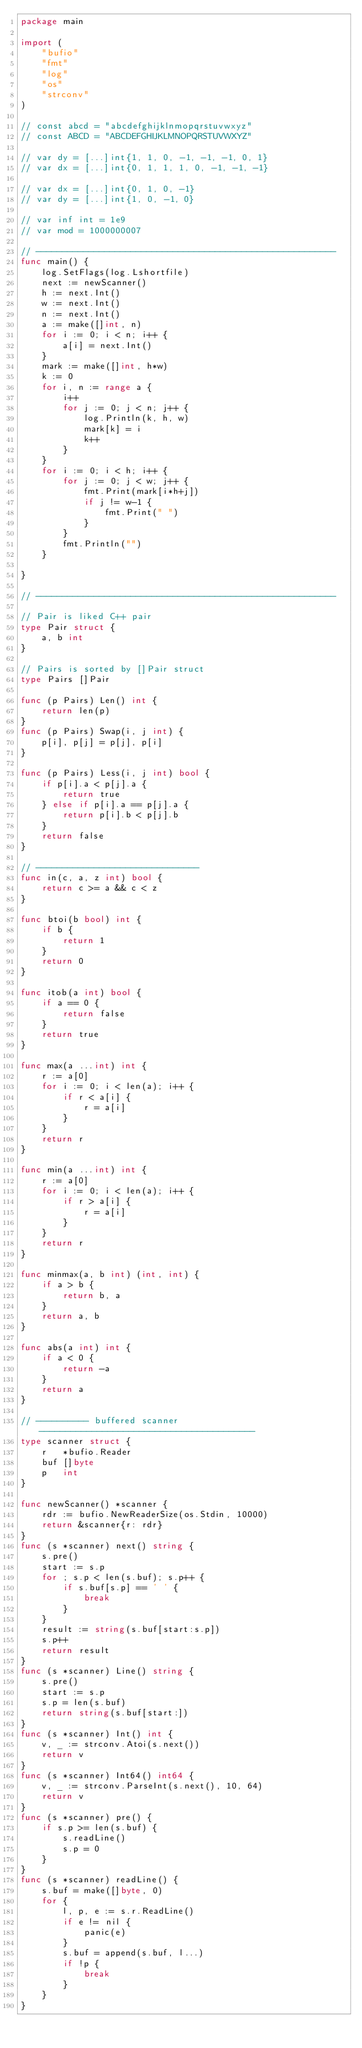Convert code to text. <code><loc_0><loc_0><loc_500><loc_500><_Go_>package main

import (
	"bufio"
	"fmt"
	"log"
	"os"
	"strconv"
)

// const abcd = "abcdefghijklnmopqrstuvwxyz"
// const ABCD = "ABCDEFGHIJKLMNOPQRSTUVWXYZ"

// var dy = [...]int{1, 1, 0, -1, -1, -1, 0, 1}
// var dx = [...]int{0, 1, 1, 1, 0, -1, -1, -1}

// var dx = [...]int{0, 1, 0, -1}
// var dy = [...]int{1, 0, -1, 0}

// var inf int = 1e9
// var mod = 1000000007

// ---------------------------------------------------------
func main() {
	log.SetFlags(log.Lshortfile)
	next := newScanner()
	h := next.Int()
	w := next.Int()
	n := next.Int()
	a := make([]int, n)
	for i := 0; i < n; i++ {
		a[i] = next.Int()
	}
	mark := make([]int, h*w)
	k := 0
	for i, n := range a {
		i++
		for j := 0; j < n; j++ {
			log.Println(k, h, w)
			mark[k] = i
			k++
		}
	}
	for i := 0; i < h; i++ {
		for j := 0; j < w; j++ {
			fmt.Print(mark[i*h+j])
			if j != w-1 {
				fmt.Print(" ")
			}
		}
		fmt.Println("")
	}

}

// ---------------------------------------------------------

// Pair is liked C++ pair
type Pair struct {
	a, b int
}

// Pairs is sorted by []Pair struct
type Pairs []Pair

func (p Pairs) Len() int {
	return len(p)
}
func (p Pairs) Swap(i, j int) {
	p[i], p[j] = p[j], p[i]
}

func (p Pairs) Less(i, j int) bool {
	if p[i].a < p[j].a {
		return true
	} else if p[i].a == p[j].a {
		return p[i].b < p[j].b
	}
	return false
}

// -------------------------------
func in(c, a, z int) bool {
	return c >= a && c < z
}

func btoi(b bool) int {
	if b {
		return 1
	}
	return 0
}

func itob(a int) bool {
	if a == 0 {
		return false
	}
	return true
}

func max(a ...int) int {
	r := a[0]
	for i := 0; i < len(a); i++ {
		if r < a[i] {
			r = a[i]
		}
	}
	return r
}

func min(a ...int) int {
	r := a[0]
	for i := 0; i < len(a); i++ {
		if r > a[i] {
			r = a[i]
		}
	}
	return r
}

func minmax(a, b int) (int, int) {
	if a > b {
		return b, a
	}
	return a, b
}

func abs(a int) int {
	if a < 0 {
		return -a
	}
	return a
}

// ---------- buffered scanner -----------------------------------------
type scanner struct {
	r   *bufio.Reader
	buf []byte
	p   int
}

func newScanner() *scanner {
	rdr := bufio.NewReaderSize(os.Stdin, 10000)
	return &scanner{r: rdr}
}
func (s *scanner) next() string {
	s.pre()
	start := s.p
	for ; s.p < len(s.buf); s.p++ {
		if s.buf[s.p] == ' ' {
			break
		}
	}
	result := string(s.buf[start:s.p])
	s.p++
	return result
}
func (s *scanner) Line() string {
	s.pre()
	start := s.p
	s.p = len(s.buf)
	return string(s.buf[start:])
}
func (s *scanner) Int() int {
	v, _ := strconv.Atoi(s.next())
	return v
}
func (s *scanner) Int64() int64 {
	v, _ := strconv.ParseInt(s.next(), 10, 64)
	return v
}
func (s *scanner) pre() {
	if s.p >= len(s.buf) {
		s.readLine()
		s.p = 0
	}
}
func (s *scanner) readLine() {
	s.buf = make([]byte, 0)
	for {
		l, p, e := s.r.ReadLine()
		if e != nil {
			panic(e)
		}
		s.buf = append(s.buf, l...)
		if !p {
			break
		}
	}
}
</code> 